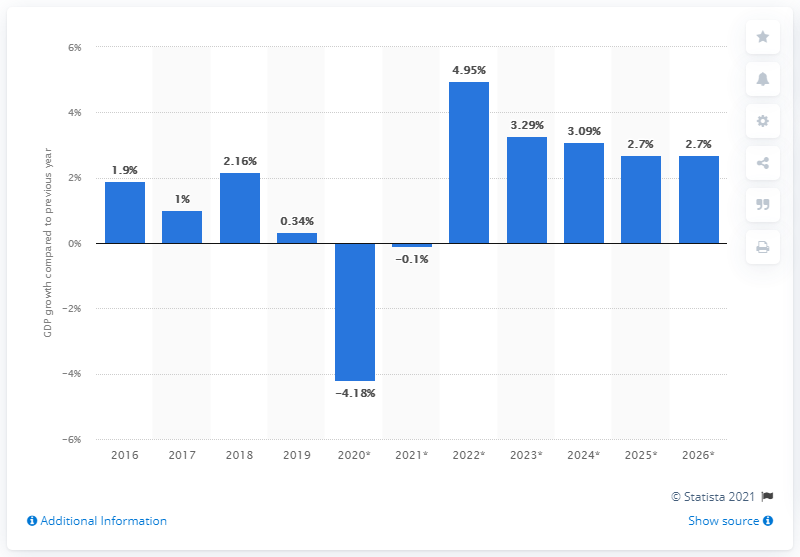Specify some key components in this picture. St. Vincent and the Grenadines' real gross domestic product grew by 0.34% in 2019. 